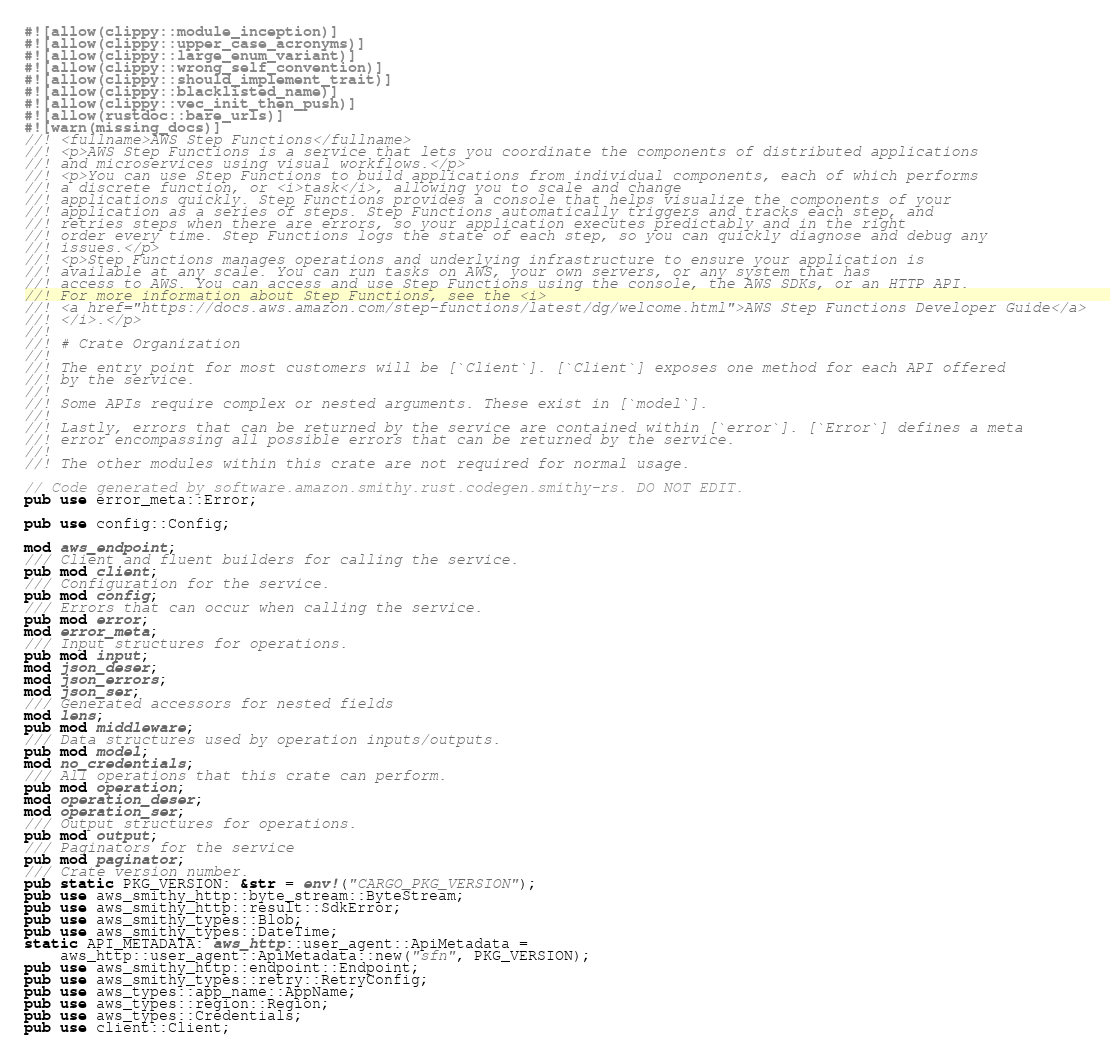<code> <loc_0><loc_0><loc_500><loc_500><_Rust_>#![allow(clippy::module_inception)]
#![allow(clippy::upper_case_acronyms)]
#![allow(clippy::large_enum_variant)]
#![allow(clippy::wrong_self_convention)]
#![allow(clippy::should_implement_trait)]
#![allow(clippy::blacklisted_name)]
#![allow(clippy::vec_init_then_push)]
#![allow(rustdoc::bare_urls)]
#![warn(missing_docs)]
//! <fullname>AWS Step Functions</fullname>
//! <p>AWS Step Functions is a service that lets you coordinate the components of distributed applications
//! and microservices using visual workflows.</p>
//! <p>You can use Step Functions to build applications from individual components, each of which performs
//! a discrete function, or <i>task</i>, allowing you to scale and change
//! applications quickly. Step Functions provides a console that helps visualize the components of your
//! application as a series of steps. Step Functions automatically triggers and tracks each step, and
//! retries steps when there are errors, so your application executes predictably and in the right
//! order every time. Step Functions logs the state of each step, so you can quickly diagnose and debug any
//! issues.</p>
//! <p>Step Functions manages operations and underlying infrastructure to ensure your application is
//! available at any scale. You can run tasks on AWS, your own servers, or any system that has
//! access to AWS. You can access and use Step Functions using the console, the AWS SDKs, or an HTTP API.
//! For more information about Step Functions, see the <i>
//! <a href="https://docs.aws.amazon.com/step-functions/latest/dg/welcome.html">AWS Step Functions Developer Guide</a>
//! </i>.</p>
//!
//! # Crate Organization
//!
//! The entry point for most customers will be [`Client`]. [`Client`] exposes one method for each API offered
//! by the service.
//!
//! Some APIs require complex or nested arguments. These exist in [`model`].
//!
//! Lastly, errors that can be returned by the service are contained within [`error`]. [`Error`] defines a meta
//! error encompassing all possible errors that can be returned by the service.
//!
//! The other modules within this crate are not required for normal usage.

// Code generated by software.amazon.smithy.rust.codegen.smithy-rs. DO NOT EDIT.
pub use error_meta::Error;

pub use config::Config;

mod aws_endpoint;
/// Client and fluent builders for calling the service.
pub mod client;
/// Configuration for the service.
pub mod config;
/// Errors that can occur when calling the service.
pub mod error;
mod error_meta;
/// Input structures for operations.
pub mod input;
mod json_deser;
mod json_errors;
mod json_ser;
/// Generated accessors for nested fields
mod lens;
pub mod middleware;
/// Data structures used by operation inputs/outputs.
pub mod model;
mod no_credentials;
/// All operations that this crate can perform.
pub mod operation;
mod operation_deser;
mod operation_ser;
/// Output structures for operations.
pub mod output;
/// Paginators for the service
pub mod paginator;
/// Crate version number.
pub static PKG_VERSION: &str = env!("CARGO_PKG_VERSION");
pub use aws_smithy_http::byte_stream::ByteStream;
pub use aws_smithy_http::result::SdkError;
pub use aws_smithy_types::Blob;
pub use aws_smithy_types::DateTime;
static API_METADATA: aws_http::user_agent::ApiMetadata =
    aws_http::user_agent::ApiMetadata::new("sfn", PKG_VERSION);
pub use aws_smithy_http::endpoint::Endpoint;
pub use aws_smithy_types::retry::RetryConfig;
pub use aws_types::app_name::AppName;
pub use aws_types::region::Region;
pub use aws_types::Credentials;
pub use client::Client;
</code> 